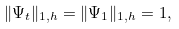<formula> <loc_0><loc_0><loc_500><loc_500>\| \Psi _ { t } \| _ { 1 , h } = \| \Psi _ { 1 } \| _ { 1 , h } = 1 ,</formula> 